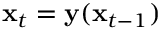Convert formula to latex. <formula><loc_0><loc_0><loc_500><loc_500>\mathbf x _ { t } = \mathbf y ( \mathbf x _ { t - 1 } )</formula> 